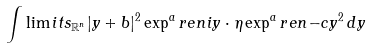<formula> <loc_0><loc_0><loc_500><loc_500>\int \lim i t s _ { \mathbb { R } ^ { n } } | y + b | ^ { 2 } \exp ^ { a } r e n { i y \cdot \eta } \exp ^ { a } r e n { - c y ^ { 2 } } \, d y</formula> 